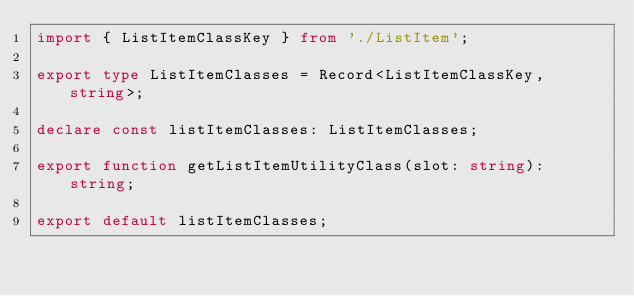Convert code to text. <code><loc_0><loc_0><loc_500><loc_500><_TypeScript_>import { ListItemClassKey } from './ListItem';

export type ListItemClasses = Record<ListItemClassKey, string>;

declare const listItemClasses: ListItemClasses;

export function getListItemUtilityClass(slot: string): string;

export default listItemClasses;
</code> 